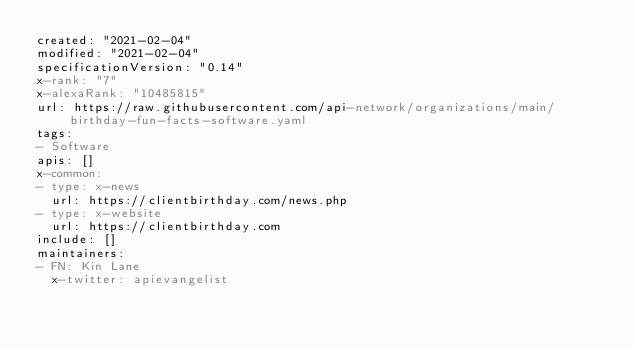<code> <loc_0><loc_0><loc_500><loc_500><_YAML_>created: "2021-02-04"
modified: "2021-02-04"
specificationVersion: "0.14"
x-rank: "7"
x-alexaRank: "10485815"
url: https://raw.githubusercontent.com/api-network/organizations/main/birthday-fun-facts-software.yaml
tags:
- Software
apis: []
x-common:
- type: x-news
  url: https://clientbirthday.com/news.php
- type: x-website
  url: https://clientbirthday.com
include: []
maintainers:
- FN: Kin Lane
  x-twitter: apievangelist</code> 